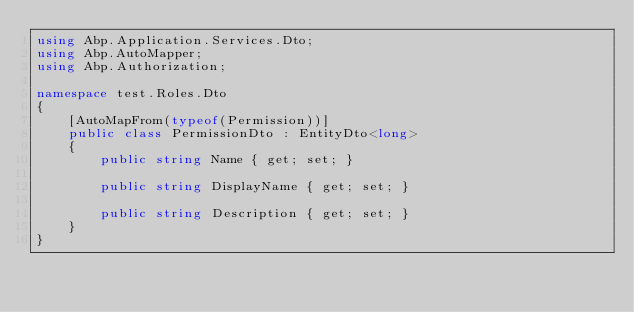<code> <loc_0><loc_0><loc_500><loc_500><_C#_>using Abp.Application.Services.Dto;
using Abp.AutoMapper;
using Abp.Authorization;

namespace test.Roles.Dto
{
    [AutoMapFrom(typeof(Permission))]
    public class PermissionDto : EntityDto<long>
    {
        public string Name { get; set; }

        public string DisplayName { get; set; }

        public string Description { get; set; }
    }
}
</code> 